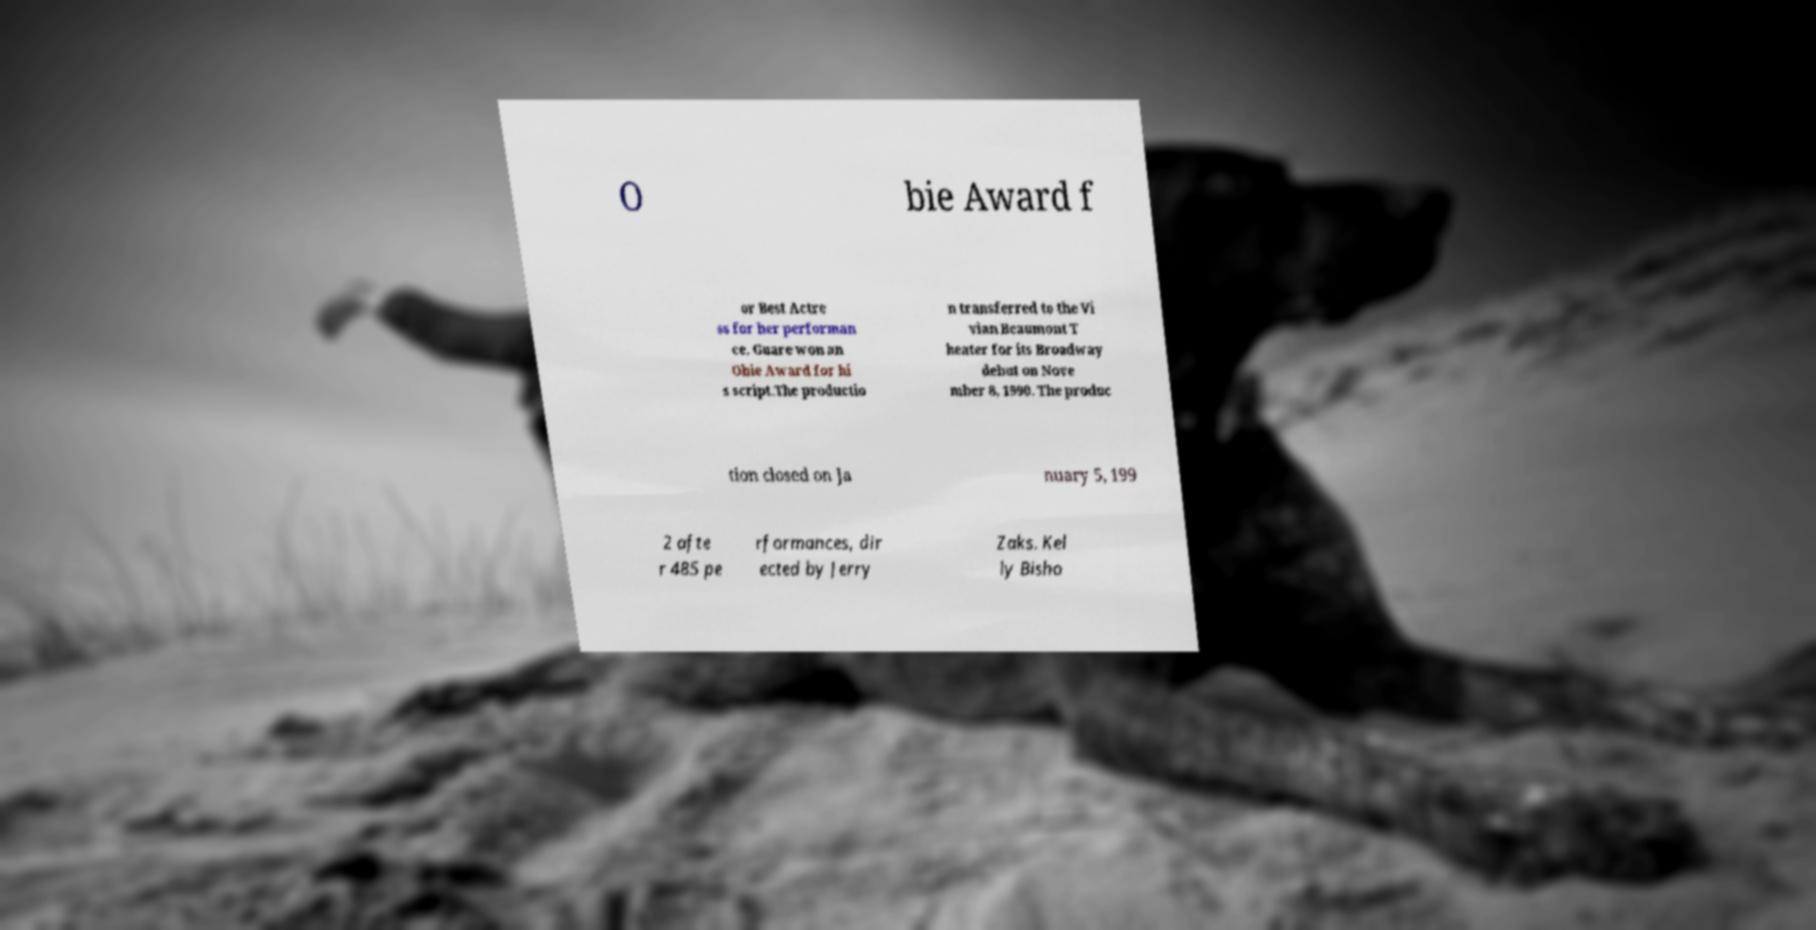For documentation purposes, I need the text within this image transcribed. Could you provide that? O bie Award f or Best Actre ss for her performan ce. Guare won an Obie Award for hi s script.The productio n transferred to the Vi vian Beaumont T heater for its Broadway debut on Nove mber 8, 1990. The produc tion closed on Ja nuary 5, 199 2 afte r 485 pe rformances, dir ected by Jerry Zaks. Kel ly Bisho 